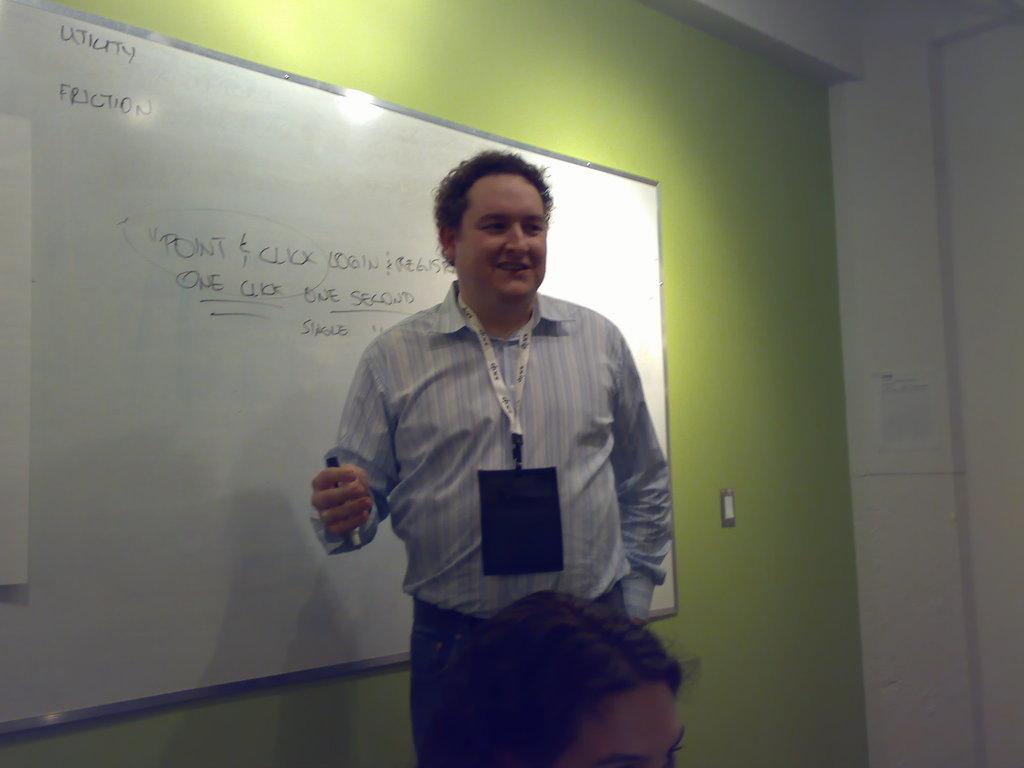What phrase is circled on the whiteboard?
Your response must be concise. Point & click. What is the topic on the whiteboard?
Your response must be concise. Point & click. 